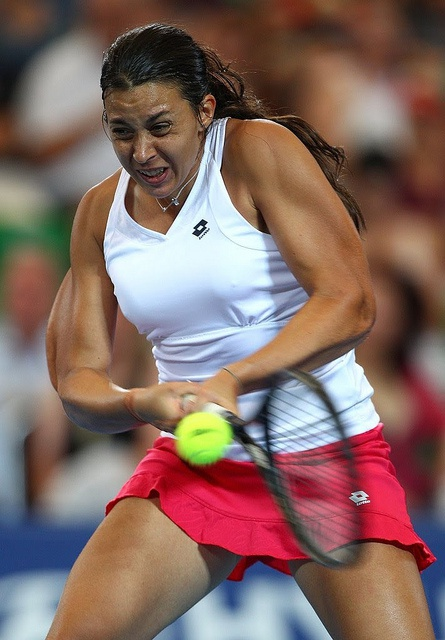Describe the objects in this image and their specific colors. I can see people in maroon, gray, lightblue, tan, and black tones, tennis racket in maroon, gray, brown, and black tones, people in maroon, black, and brown tones, people in maroon, brown, gray, and darkgray tones, and people in maroon, black, and gray tones in this image. 